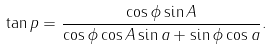Convert formula to latex. <formula><loc_0><loc_0><loc_500><loc_500>\tan p = \frac { \cos \phi \sin A } { \cos \phi \cos A \sin a + \sin \phi \cos a } .</formula> 